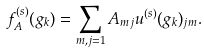<formula> <loc_0><loc_0><loc_500><loc_500>f _ { A } ^ { ( s ) } ( g _ { k } ) = \sum _ { m , j = 1 } A _ { m j } u ^ { ( s ) } ( g _ { k } ) _ { j m } .</formula> 